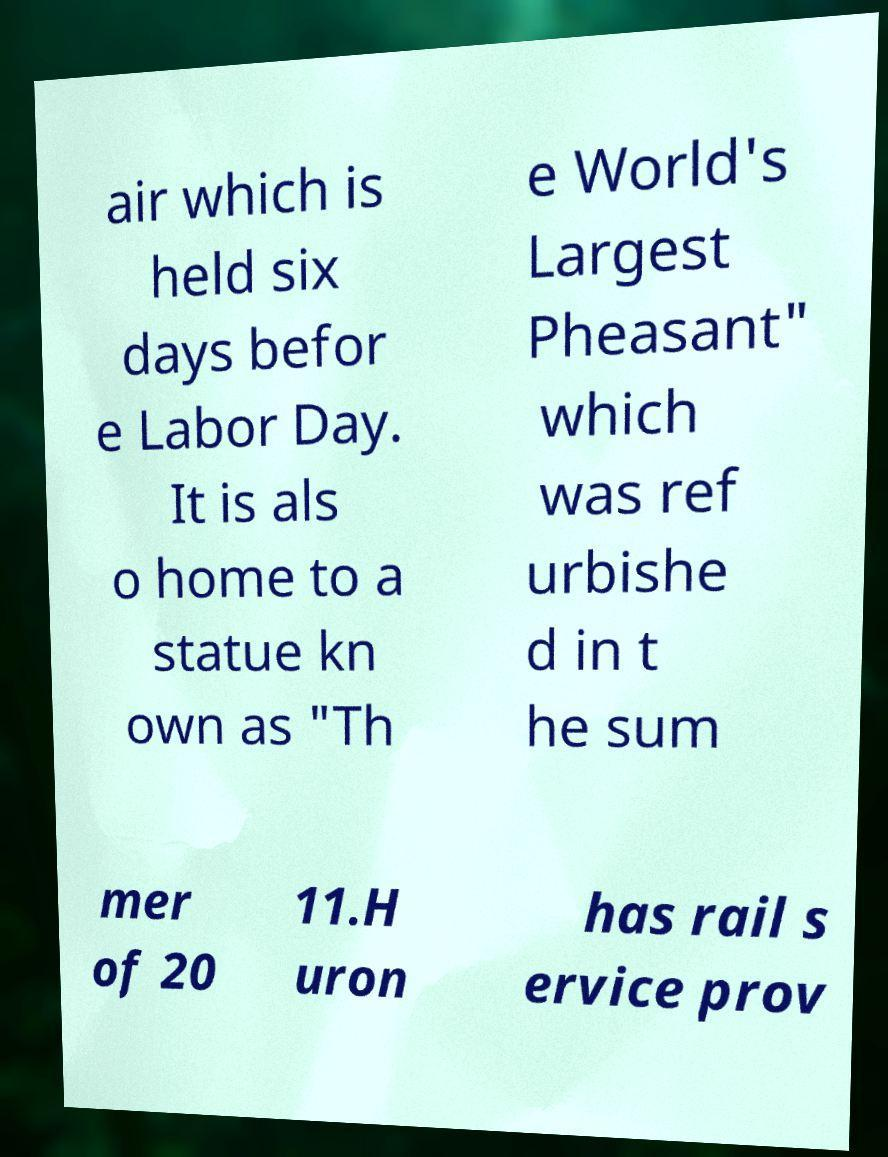Can you accurately transcribe the text from the provided image for me? air which is held six days befor e Labor Day. It is als o home to a statue kn own as "Th e World's Largest Pheasant" which was ref urbishe d in t he sum mer of 20 11.H uron has rail s ervice prov 